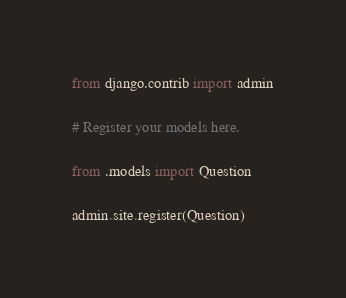<code> <loc_0><loc_0><loc_500><loc_500><_Python_>from django.contrib import admin

# Register your models here.

from .models import Question

admin.site.register(Question) </code> 